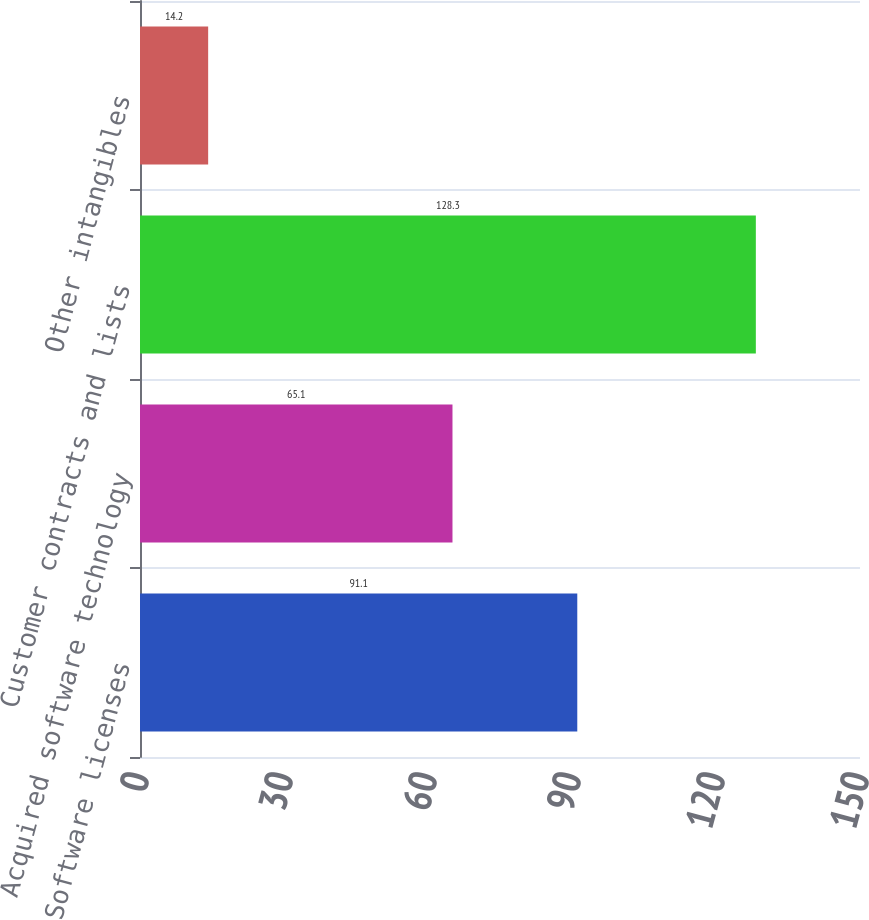Convert chart to OTSL. <chart><loc_0><loc_0><loc_500><loc_500><bar_chart><fcel>Software licenses<fcel>Acquired software technology<fcel>Customer contracts and lists<fcel>Other intangibles<nl><fcel>91.1<fcel>65.1<fcel>128.3<fcel>14.2<nl></chart> 